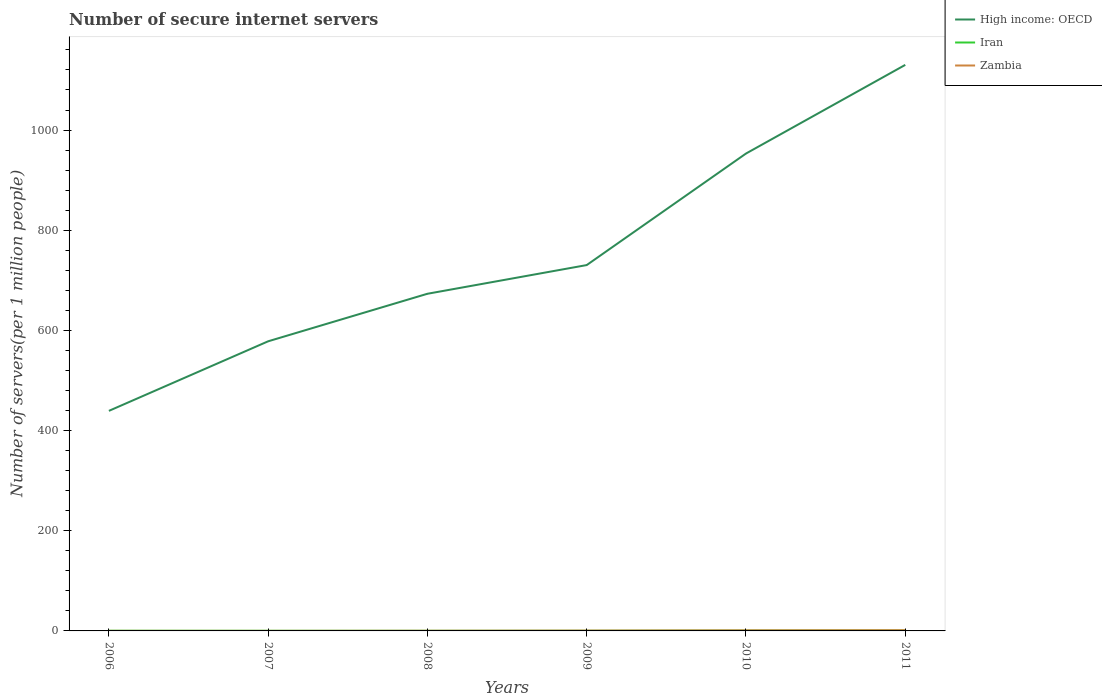Does the line corresponding to Zambia intersect with the line corresponding to High income: OECD?
Offer a very short reply. No. Is the number of lines equal to the number of legend labels?
Your answer should be compact. Yes. Across all years, what is the maximum number of secure internet servers in Zambia?
Your response must be concise. 0.08. What is the total number of secure internet servers in Zambia in the graph?
Your answer should be very brief. -0.23. What is the difference between the highest and the second highest number of secure internet servers in Zambia?
Make the answer very short. 1.39. Does the graph contain any zero values?
Offer a very short reply. No. Does the graph contain grids?
Keep it short and to the point. No. Where does the legend appear in the graph?
Offer a terse response. Top right. How many legend labels are there?
Make the answer very short. 3. How are the legend labels stacked?
Offer a terse response. Vertical. What is the title of the graph?
Offer a terse response. Number of secure internet servers. What is the label or title of the Y-axis?
Your response must be concise. Number of servers(per 1 million people). What is the Number of servers(per 1 million people) in High income: OECD in 2006?
Your response must be concise. 439.34. What is the Number of servers(per 1 million people) of Iran in 2006?
Your response must be concise. 0.39. What is the Number of servers(per 1 million people) in Zambia in 2006?
Your answer should be compact. 0.08. What is the Number of servers(per 1 million people) in High income: OECD in 2007?
Give a very brief answer. 578.25. What is the Number of servers(per 1 million people) of Iran in 2007?
Your response must be concise. 0.31. What is the Number of servers(per 1 million people) in Zambia in 2007?
Provide a short and direct response. 0.08. What is the Number of servers(per 1 million people) in High income: OECD in 2008?
Your answer should be very brief. 673.14. What is the Number of servers(per 1 million people) in Iran in 2008?
Offer a terse response. 0.28. What is the Number of servers(per 1 million people) in Zambia in 2008?
Provide a short and direct response. 0.31. What is the Number of servers(per 1 million people) in High income: OECD in 2009?
Keep it short and to the point. 730.41. What is the Number of servers(per 1 million people) in Iran in 2009?
Keep it short and to the point. 0.33. What is the Number of servers(per 1 million people) of Zambia in 2009?
Your answer should be very brief. 0.67. What is the Number of servers(per 1 million people) of High income: OECD in 2010?
Ensure brevity in your answer.  953.1. What is the Number of servers(per 1 million people) of Iran in 2010?
Give a very brief answer. 0.74. What is the Number of servers(per 1 million people) in Zambia in 2010?
Your answer should be compact. 1.15. What is the Number of servers(per 1 million people) of High income: OECD in 2011?
Keep it short and to the point. 1130.1. What is the Number of servers(per 1 million people) of Iran in 2011?
Offer a very short reply. 1.01. What is the Number of servers(per 1 million people) in Zambia in 2011?
Make the answer very short. 1.46. Across all years, what is the maximum Number of servers(per 1 million people) of High income: OECD?
Keep it short and to the point. 1130.1. Across all years, what is the maximum Number of servers(per 1 million people) in Iran?
Give a very brief answer. 1.01. Across all years, what is the maximum Number of servers(per 1 million people) in Zambia?
Provide a short and direct response. 1.46. Across all years, what is the minimum Number of servers(per 1 million people) in High income: OECD?
Provide a succinct answer. 439.34. Across all years, what is the minimum Number of servers(per 1 million people) in Iran?
Make the answer very short. 0.28. Across all years, what is the minimum Number of servers(per 1 million people) in Zambia?
Offer a terse response. 0.08. What is the total Number of servers(per 1 million people) of High income: OECD in the graph?
Provide a succinct answer. 4504.35. What is the total Number of servers(per 1 million people) of Iran in the graph?
Your answer should be very brief. 3.06. What is the total Number of servers(per 1 million people) of Zambia in the graph?
Provide a succinct answer. 3.74. What is the difference between the Number of servers(per 1 million people) in High income: OECD in 2006 and that in 2007?
Provide a short and direct response. -138.9. What is the difference between the Number of servers(per 1 million people) in Iran in 2006 and that in 2007?
Your answer should be compact. 0.09. What is the difference between the Number of servers(per 1 million people) in Zambia in 2006 and that in 2007?
Make the answer very short. 0. What is the difference between the Number of servers(per 1 million people) of High income: OECD in 2006 and that in 2008?
Your answer should be very brief. -233.79. What is the difference between the Number of servers(per 1 million people) in Iran in 2006 and that in 2008?
Offer a very short reply. 0.12. What is the difference between the Number of servers(per 1 million people) of Zambia in 2006 and that in 2008?
Ensure brevity in your answer.  -0.22. What is the difference between the Number of servers(per 1 million people) of High income: OECD in 2006 and that in 2009?
Keep it short and to the point. -291.07. What is the difference between the Number of servers(per 1 million people) in Iran in 2006 and that in 2009?
Offer a terse response. 0.07. What is the difference between the Number of servers(per 1 million people) of Zambia in 2006 and that in 2009?
Provide a succinct answer. -0.59. What is the difference between the Number of servers(per 1 million people) in High income: OECD in 2006 and that in 2010?
Provide a short and direct response. -513.76. What is the difference between the Number of servers(per 1 million people) in Iran in 2006 and that in 2010?
Give a very brief answer. -0.35. What is the difference between the Number of servers(per 1 million people) of Zambia in 2006 and that in 2010?
Your response must be concise. -1.07. What is the difference between the Number of servers(per 1 million people) in High income: OECD in 2006 and that in 2011?
Offer a terse response. -690.76. What is the difference between the Number of servers(per 1 million people) of Iran in 2006 and that in 2011?
Offer a terse response. -0.62. What is the difference between the Number of servers(per 1 million people) in Zambia in 2006 and that in 2011?
Your answer should be very brief. -1.38. What is the difference between the Number of servers(per 1 million people) of High income: OECD in 2007 and that in 2008?
Provide a succinct answer. -94.89. What is the difference between the Number of servers(per 1 million people) in Iran in 2007 and that in 2008?
Give a very brief answer. 0.03. What is the difference between the Number of servers(per 1 million people) of Zambia in 2007 and that in 2008?
Your response must be concise. -0.23. What is the difference between the Number of servers(per 1 million people) of High income: OECD in 2007 and that in 2009?
Give a very brief answer. -152.17. What is the difference between the Number of servers(per 1 million people) of Iran in 2007 and that in 2009?
Keep it short and to the point. -0.02. What is the difference between the Number of servers(per 1 million people) in Zambia in 2007 and that in 2009?
Keep it short and to the point. -0.59. What is the difference between the Number of servers(per 1 million people) of High income: OECD in 2007 and that in 2010?
Provide a short and direct response. -374.85. What is the difference between the Number of servers(per 1 million people) in Iran in 2007 and that in 2010?
Your answer should be very brief. -0.43. What is the difference between the Number of servers(per 1 million people) of Zambia in 2007 and that in 2010?
Make the answer very short. -1.07. What is the difference between the Number of servers(per 1 million people) of High income: OECD in 2007 and that in 2011?
Your answer should be very brief. -551.85. What is the difference between the Number of servers(per 1 million people) in Iran in 2007 and that in 2011?
Offer a terse response. -0.7. What is the difference between the Number of servers(per 1 million people) in Zambia in 2007 and that in 2011?
Offer a terse response. -1.39. What is the difference between the Number of servers(per 1 million people) of High income: OECD in 2008 and that in 2009?
Offer a very short reply. -57.28. What is the difference between the Number of servers(per 1 million people) in Iran in 2008 and that in 2009?
Offer a very short reply. -0.05. What is the difference between the Number of servers(per 1 million people) of Zambia in 2008 and that in 2009?
Offer a terse response. -0.36. What is the difference between the Number of servers(per 1 million people) of High income: OECD in 2008 and that in 2010?
Your answer should be compact. -279.97. What is the difference between the Number of servers(per 1 million people) of Iran in 2008 and that in 2010?
Your answer should be very brief. -0.47. What is the difference between the Number of servers(per 1 million people) in Zambia in 2008 and that in 2010?
Offer a terse response. -0.84. What is the difference between the Number of servers(per 1 million people) of High income: OECD in 2008 and that in 2011?
Keep it short and to the point. -456.96. What is the difference between the Number of servers(per 1 million people) in Iran in 2008 and that in 2011?
Make the answer very short. -0.74. What is the difference between the Number of servers(per 1 million people) in Zambia in 2008 and that in 2011?
Your response must be concise. -1.16. What is the difference between the Number of servers(per 1 million people) in High income: OECD in 2009 and that in 2010?
Provide a short and direct response. -222.69. What is the difference between the Number of servers(per 1 million people) in Iran in 2009 and that in 2010?
Offer a terse response. -0.41. What is the difference between the Number of servers(per 1 million people) of Zambia in 2009 and that in 2010?
Your response must be concise. -0.48. What is the difference between the Number of servers(per 1 million people) in High income: OECD in 2009 and that in 2011?
Provide a short and direct response. -399.69. What is the difference between the Number of servers(per 1 million people) of Iran in 2009 and that in 2011?
Ensure brevity in your answer.  -0.68. What is the difference between the Number of servers(per 1 million people) of Zambia in 2009 and that in 2011?
Offer a very short reply. -0.8. What is the difference between the Number of servers(per 1 million people) in High income: OECD in 2010 and that in 2011?
Offer a terse response. -177. What is the difference between the Number of servers(per 1 million people) of Iran in 2010 and that in 2011?
Make the answer very short. -0.27. What is the difference between the Number of servers(per 1 million people) of Zambia in 2010 and that in 2011?
Your response must be concise. -0.31. What is the difference between the Number of servers(per 1 million people) of High income: OECD in 2006 and the Number of servers(per 1 million people) of Iran in 2007?
Offer a terse response. 439.04. What is the difference between the Number of servers(per 1 million people) in High income: OECD in 2006 and the Number of servers(per 1 million people) in Zambia in 2007?
Ensure brevity in your answer.  439.27. What is the difference between the Number of servers(per 1 million people) of Iran in 2006 and the Number of servers(per 1 million people) of Zambia in 2007?
Your answer should be very brief. 0.32. What is the difference between the Number of servers(per 1 million people) of High income: OECD in 2006 and the Number of servers(per 1 million people) of Iran in 2008?
Offer a terse response. 439.07. What is the difference between the Number of servers(per 1 million people) in High income: OECD in 2006 and the Number of servers(per 1 million people) in Zambia in 2008?
Ensure brevity in your answer.  439.04. What is the difference between the Number of servers(per 1 million people) in Iran in 2006 and the Number of servers(per 1 million people) in Zambia in 2008?
Offer a very short reply. 0.09. What is the difference between the Number of servers(per 1 million people) of High income: OECD in 2006 and the Number of servers(per 1 million people) of Iran in 2009?
Your response must be concise. 439.02. What is the difference between the Number of servers(per 1 million people) of High income: OECD in 2006 and the Number of servers(per 1 million people) of Zambia in 2009?
Ensure brevity in your answer.  438.68. What is the difference between the Number of servers(per 1 million people) of Iran in 2006 and the Number of servers(per 1 million people) of Zambia in 2009?
Offer a terse response. -0.27. What is the difference between the Number of servers(per 1 million people) of High income: OECD in 2006 and the Number of servers(per 1 million people) of Iran in 2010?
Make the answer very short. 438.6. What is the difference between the Number of servers(per 1 million people) in High income: OECD in 2006 and the Number of servers(per 1 million people) in Zambia in 2010?
Provide a short and direct response. 438.2. What is the difference between the Number of servers(per 1 million people) of Iran in 2006 and the Number of servers(per 1 million people) of Zambia in 2010?
Your response must be concise. -0.75. What is the difference between the Number of servers(per 1 million people) in High income: OECD in 2006 and the Number of servers(per 1 million people) in Iran in 2011?
Provide a short and direct response. 438.33. What is the difference between the Number of servers(per 1 million people) of High income: OECD in 2006 and the Number of servers(per 1 million people) of Zambia in 2011?
Offer a very short reply. 437.88. What is the difference between the Number of servers(per 1 million people) of Iran in 2006 and the Number of servers(per 1 million people) of Zambia in 2011?
Make the answer very short. -1.07. What is the difference between the Number of servers(per 1 million people) of High income: OECD in 2007 and the Number of servers(per 1 million people) of Iran in 2008?
Give a very brief answer. 577.97. What is the difference between the Number of servers(per 1 million people) in High income: OECD in 2007 and the Number of servers(per 1 million people) in Zambia in 2008?
Make the answer very short. 577.94. What is the difference between the Number of servers(per 1 million people) in Iran in 2007 and the Number of servers(per 1 million people) in Zambia in 2008?
Keep it short and to the point. 0. What is the difference between the Number of servers(per 1 million people) of High income: OECD in 2007 and the Number of servers(per 1 million people) of Iran in 2009?
Ensure brevity in your answer.  577.92. What is the difference between the Number of servers(per 1 million people) of High income: OECD in 2007 and the Number of servers(per 1 million people) of Zambia in 2009?
Ensure brevity in your answer.  577.58. What is the difference between the Number of servers(per 1 million people) of Iran in 2007 and the Number of servers(per 1 million people) of Zambia in 2009?
Provide a succinct answer. -0.36. What is the difference between the Number of servers(per 1 million people) of High income: OECD in 2007 and the Number of servers(per 1 million people) of Iran in 2010?
Keep it short and to the point. 577.51. What is the difference between the Number of servers(per 1 million people) in High income: OECD in 2007 and the Number of servers(per 1 million people) in Zambia in 2010?
Provide a succinct answer. 577.1. What is the difference between the Number of servers(per 1 million people) of Iran in 2007 and the Number of servers(per 1 million people) of Zambia in 2010?
Your answer should be very brief. -0.84. What is the difference between the Number of servers(per 1 million people) in High income: OECD in 2007 and the Number of servers(per 1 million people) in Iran in 2011?
Give a very brief answer. 577.24. What is the difference between the Number of servers(per 1 million people) in High income: OECD in 2007 and the Number of servers(per 1 million people) in Zambia in 2011?
Offer a very short reply. 576.78. What is the difference between the Number of servers(per 1 million people) in Iran in 2007 and the Number of servers(per 1 million people) in Zambia in 2011?
Provide a short and direct response. -1.16. What is the difference between the Number of servers(per 1 million people) of High income: OECD in 2008 and the Number of servers(per 1 million people) of Iran in 2009?
Provide a succinct answer. 672.81. What is the difference between the Number of servers(per 1 million people) in High income: OECD in 2008 and the Number of servers(per 1 million people) in Zambia in 2009?
Offer a terse response. 672.47. What is the difference between the Number of servers(per 1 million people) in Iran in 2008 and the Number of servers(per 1 million people) in Zambia in 2009?
Offer a very short reply. -0.39. What is the difference between the Number of servers(per 1 million people) of High income: OECD in 2008 and the Number of servers(per 1 million people) of Iran in 2010?
Offer a terse response. 672.4. What is the difference between the Number of servers(per 1 million people) of High income: OECD in 2008 and the Number of servers(per 1 million people) of Zambia in 2010?
Keep it short and to the point. 671.99. What is the difference between the Number of servers(per 1 million people) of Iran in 2008 and the Number of servers(per 1 million people) of Zambia in 2010?
Make the answer very short. -0.87. What is the difference between the Number of servers(per 1 million people) in High income: OECD in 2008 and the Number of servers(per 1 million people) in Iran in 2011?
Offer a very short reply. 672.13. What is the difference between the Number of servers(per 1 million people) of High income: OECD in 2008 and the Number of servers(per 1 million people) of Zambia in 2011?
Make the answer very short. 671.67. What is the difference between the Number of servers(per 1 million people) of Iran in 2008 and the Number of servers(per 1 million people) of Zambia in 2011?
Your answer should be compact. -1.19. What is the difference between the Number of servers(per 1 million people) of High income: OECD in 2009 and the Number of servers(per 1 million people) of Iran in 2010?
Make the answer very short. 729.67. What is the difference between the Number of servers(per 1 million people) in High income: OECD in 2009 and the Number of servers(per 1 million people) in Zambia in 2010?
Your response must be concise. 729.26. What is the difference between the Number of servers(per 1 million people) of Iran in 2009 and the Number of servers(per 1 million people) of Zambia in 2010?
Offer a very short reply. -0.82. What is the difference between the Number of servers(per 1 million people) of High income: OECD in 2009 and the Number of servers(per 1 million people) of Iran in 2011?
Your answer should be compact. 729.4. What is the difference between the Number of servers(per 1 million people) in High income: OECD in 2009 and the Number of servers(per 1 million people) in Zambia in 2011?
Make the answer very short. 728.95. What is the difference between the Number of servers(per 1 million people) in Iran in 2009 and the Number of servers(per 1 million people) in Zambia in 2011?
Your answer should be very brief. -1.14. What is the difference between the Number of servers(per 1 million people) in High income: OECD in 2010 and the Number of servers(per 1 million people) in Iran in 2011?
Ensure brevity in your answer.  952.09. What is the difference between the Number of servers(per 1 million people) of High income: OECD in 2010 and the Number of servers(per 1 million people) of Zambia in 2011?
Offer a terse response. 951.64. What is the difference between the Number of servers(per 1 million people) of Iran in 2010 and the Number of servers(per 1 million people) of Zambia in 2011?
Ensure brevity in your answer.  -0.72. What is the average Number of servers(per 1 million people) of High income: OECD per year?
Your answer should be very brief. 750.72. What is the average Number of servers(per 1 million people) in Iran per year?
Your answer should be very brief. 0.51. What is the average Number of servers(per 1 million people) of Zambia per year?
Make the answer very short. 0.62. In the year 2006, what is the difference between the Number of servers(per 1 million people) in High income: OECD and Number of servers(per 1 million people) in Iran?
Give a very brief answer. 438.95. In the year 2006, what is the difference between the Number of servers(per 1 million people) in High income: OECD and Number of servers(per 1 million people) in Zambia?
Your response must be concise. 439.26. In the year 2006, what is the difference between the Number of servers(per 1 million people) in Iran and Number of servers(per 1 million people) in Zambia?
Provide a short and direct response. 0.31. In the year 2007, what is the difference between the Number of servers(per 1 million people) of High income: OECD and Number of servers(per 1 million people) of Iran?
Keep it short and to the point. 577.94. In the year 2007, what is the difference between the Number of servers(per 1 million people) of High income: OECD and Number of servers(per 1 million people) of Zambia?
Offer a very short reply. 578.17. In the year 2007, what is the difference between the Number of servers(per 1 million people) of Iran and Number of servers(per 1 million people) of Zambia?
Give a very brief answer. 0.23. In the year 2008, what is the difference between the Number of servers(per 1 million people) of High income: OECD and Number of servers(per 1 million people) of Iran?
Make the answer very short. 672.86. In the year 2008, what is the difference between the Number of servers(per 1 million people) in High income: OECD and Number of servers(per 1 million people) in Zambia?
Make the answer very short. 672.83. In the year 2008, what is the difference between the Number of servers(per 1 million people) in Iran and Number of servers(per 1 million people) in Zambia?
Give a very brief answer. -0.03. In the year 2009, what is the difference between the Number of servers(per 1 million people) in High income: OECD and Number of servers(per 1 million people) in Iran?
Ensure brevity in your answer.  730.09. In the year 2009, what is the difference between the Number of servers(per 1 million people) in High income: OECD and Number of servers(per 1 million people) in Zambia?
Offer a terse response. 729.75. In the year 2009, what is the difference between the Number of servers(per 1 million people) of Iran and Number of servers(per 1 million people) of Zambia?
Your answer should be compact. -0.34. In the year 2010, what is the difference between the Number of servers(per 1 million people) in High income: OECD and Number of servers(per 1 million people) in Iran?
Offer a terse response. 952.36. In the year 2010, what is the difference between the Number of servers(per 1 million people) in High income: OECD and Number of servers(per 1 million people) in Zambia?
Your answer should be very brief. 951.95. In the year 2010, what is the difference between the Number of servers(per 1 million people) in Iran and Number of servers(per 1 million people) in Zambia?
Keep it short and to the point. -0.41. In the year 2011, what is the difference between the Number of servers(per 1 million people) in High income: OECD and Number of servers(per 1 million people) in Iran?
Offer a terse response. 1129.09. In the year 2011, what is the difference between the Number of servers(per 1 million people) in High income: OECD and Number of servers(per 1 million people) in Zambia?
Your response must be concise. 1128.64. In the year 2011, what is the difference between the Number of servers(per 1 million people) of Iran and Number of servers(per 1 million people) of Zambia?
Ensure brevity in your answer.  -0.45. What is the ratio of the Number of servers(per 1 million people) of High income: OECD in 2006 to that in 2007?
Make the answer very short. 0.76. What is the ratio of the Number of servers(per 1 million people) of Iran in 2006 to that in 2007?
Your response must be concise. 1.29. What is the ratio of the Number of servers(per 1 million people) of Zambia in 2006 to that in 2007?
Give a very brief answer. 1.03. What is the ratio of the Number of servers(per 1 million people) in High income: OECD in 2006 to that in 2008?
Provide a short and direct response. 0.65. What is the ratio of the Number of servers(per 1 million people) of Iran in 2006 to that in 2008?
Provide a short and direct response. 1.43. What is the ratio of the Number of servers(per 1 million people) in Zambia in 2006 to that in 2008?
Offer a terse response. 0.26. What is the ratio of the Number of servers(per 1 million people) of High income: OECD in 2006 to that in 2009?
Offer a terse response. 0.6. What is the ratio of the Number of servers(per 1 million people) of Iran in 2006 to that in 2009?
Keep it short and to the point. 1.21. What is the ratio of the Number of servers(per 1 million people) in Zambia in 2006 to that in 2009?
Provide a short and direct response. 0.12. What is the ratio of the Number of servers(per 1 million people) in High income: OECD in 2006 to that in 2010?
Your answer should be very brief. 0.46. What is the ratio of the Number of servers(per 1 million people) of Iran in 2006 to that in 2010?
Your response must be concise. 0.53. What is the ratio of the Number of servers(per 1 million people) in Zambia in 2006 to that in 2010?
Ensure brevity in your answer.  0.07. What is the ratio of the Number of servers(per 1 million people) in High income: OECD in 2006 to that in 2011?
Provide a succinct answer. 0.39. What is the ratio of the Number of servers(per 1 million people) of Iran in 2006 to that in 2011?
Your answer should be compact. 0.39. What is the ratio of the Number of servers(per 1 million people) of Zambia in 2006 to that in 2011?
Offer a very short reply. 0.06. What is the ratio of the Number of servers(per 1 million people) of High income: OECD in 2007 to that in 2008?
Ensure brevity in your answer.  0.86. What is the ratio of the Number of servers(per 1 million people) of Iran in 2007 to that in 2008?
Give a very brief answer. 1.11. What is the ratio of the Number of servers(per 1 million people) in Zambia in 2007 to that in 2008?
Make the answer very short. 0.26. What is the ratio of the Number of servers(per 1 million people) of High income: OECD in 2007 to that in 2009?
Keep it short and to the point. 0.79. What is the ratio of the Number of servers(per 1 million people) of Iran in 2007 to that in 2009?
Your answer should be compact. 0.94. What is the ratio of the Number of servers(per 1 million people) in Zambia in 2007 to that in 2009?
Give a very brief answer. 0.12. What is the ratio of the Number of servers(per 1 million people) in High income: OECD in 2007 to that in 2010?
Provide a succinct answer. 0.61. What is the ratio of the Number of servers(per 1 million people) of Iran in 2007 to that in 2010?
Your answer should be very brief. 0.41. What is the ratio of the Number of servers(per 1 million people) of Zambia in 2007 to that in 2010?
Give a very brief answer. 0.07. What is the ratio of the Number of servers(per 1 million people) of High income: OECD in 2007 to that in 2011?
Your response must be concise. 0.51. What is the ratio of the Number of servers(per 1 million people) of Iran in 2007 to that in 2011?
Provide a succinct answer. 0.3. What is the ratio of the Number of servers(per 1 million people) of Zambia in 2007 to that in 2011?
Your answer should be compact. 0.05. What is the ratio of the Number of servers(per 1 million people) in High income: OECD in 2008 to that in 2009?
Keep it short and to the point. 0.92. What is the ratio of the Number of servers(per 1 million people) of Iran in 2008 to that in 2009?
Provide a succinct answer. 0.84. What is the ratio of the Number of servers(per 1 million people) of Zambia in 2008 to that in 2009?
Your answer should be compact. 0.46. What is the ratio of the Number of servers(per 1 million people) of High income: OECD in 2008 to that in 2010?
Keep it short and to the point. 0.71. What is the ratio of the Number of servers(per 1 million people) in Iran in 2008 to that in 2010?
Your answer should be compact. 0.37. What is the ratio of the Number of servers(per 1 million people) of Zambia in 2008 to that in 2010?
Keep it short and to the point. 0.27. What is the ratio of the Number of servers(per 1 million people) of High income: OECD in 2008 to that in 2011?
Give a very brief answer. 0.6. What is the ratio of the Number of servers(per 1 million people) in Iran in 2008 to that in 2011?
Provide a short and direct response. 0.27. What is the ratio of the Number of servers(per 1 million people) of Zambia in 2008 to that in 2011?
Make the answer very short. 0.21. What is the ratio of the Number of servers(per 1 million people) in High income: OECD in 2009 to that in 2010?
Ensure brevity in your answer.  0.77. What is the ratio of the Number of servers(per 1 million people) in Iran in 2009 to that in 2010?
Offer a terse response. 0.44. What is the ratio of the Number of servers(per 1 million people) in Zambia in 2009 to that in 2010?
Make the answer very short. 0.58. What is the ratio of the Number of servers(per 1 million people) of High income: OECD in 2009 to that in 2011?
Your answer should be compact. 0.65. What is the ratio of the Number of servers(per 1 million people) of Iran in 2009 to that in 2011?
Provide a succinct answer. 0.32. What is the ratio of the Number of servers(per 1 million people) of Zambia in 2009 to that in 2011?
Your response must be concise. 0.46. What is the ratio of the Number of servers(per 1 million people) of High income: OECD in 2010 to that in 2011?
Your answer should be very brief. 0.84. What is the ratio of the Number of servers(per 1 million people) in Iran in 2010 to that in 2011?
Offer a very short reply. 0.73. What is the ratio of the Number of servers(per 1 million people) of Zambia in 2010 to that in 2011?
Give a very brief answer. 0.79. What is the difference between the highest and the second highest Number of servers(per 1 million people) of High income: OECD?
Ensure brevity in your answer.  177. What is the difference between the highest and the second highest Number of servers(per 1 million people) in Iran?
Keep it short and to the point. 0.27. What is the difference between the highest and the second highest Number of servers(per 1 million people) in Zambia?
Ensure brevity in your answer.  0.31. What is the difference between the highest and the lowest Number of servers(per 1 million people) in High income: OECD?
Provide a succinct answer. 690.76. What is the difference between the highest and the lowest Number of servers(per 1 million people) in Iran?
Offer a terse response. 0.74. What is the difference between the highest and the lowest Number of servers(per 1 million people) in Zambia?
Offer a terse response. 1.39. 